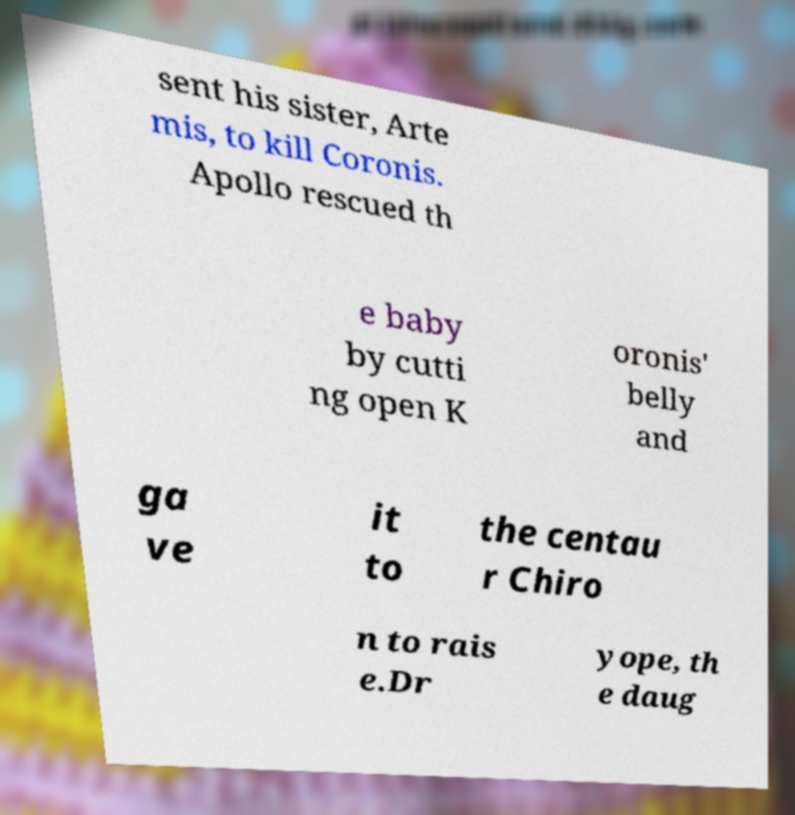I need the written content from this picture converted into text. Can you do that? sent his sister, Arte mis, to kill Coronis. Apollo rescued th e baby by cutti ng open K oronis' belly and ga ve it to the centau r Chiro n to rais e.Dr yope, th e daug 